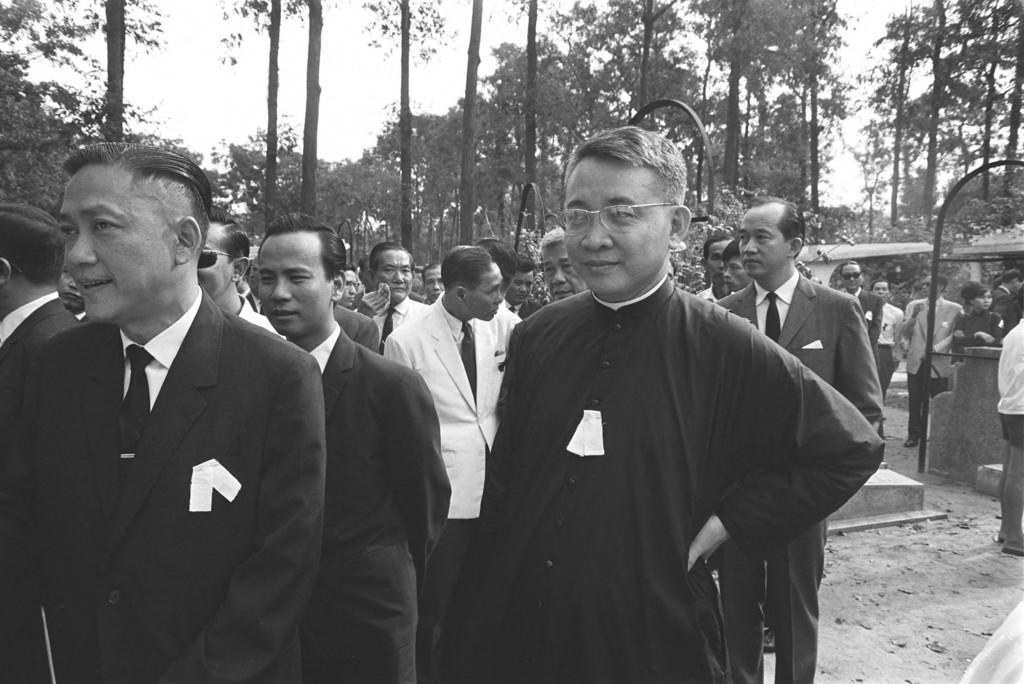Could you give a brief overview of what you see in this image? In this picture I can see there are many people walking and they are wearing black color coats and in the right the person is wearing spectacles and there are trees in the backdrop and the sky is clear. 